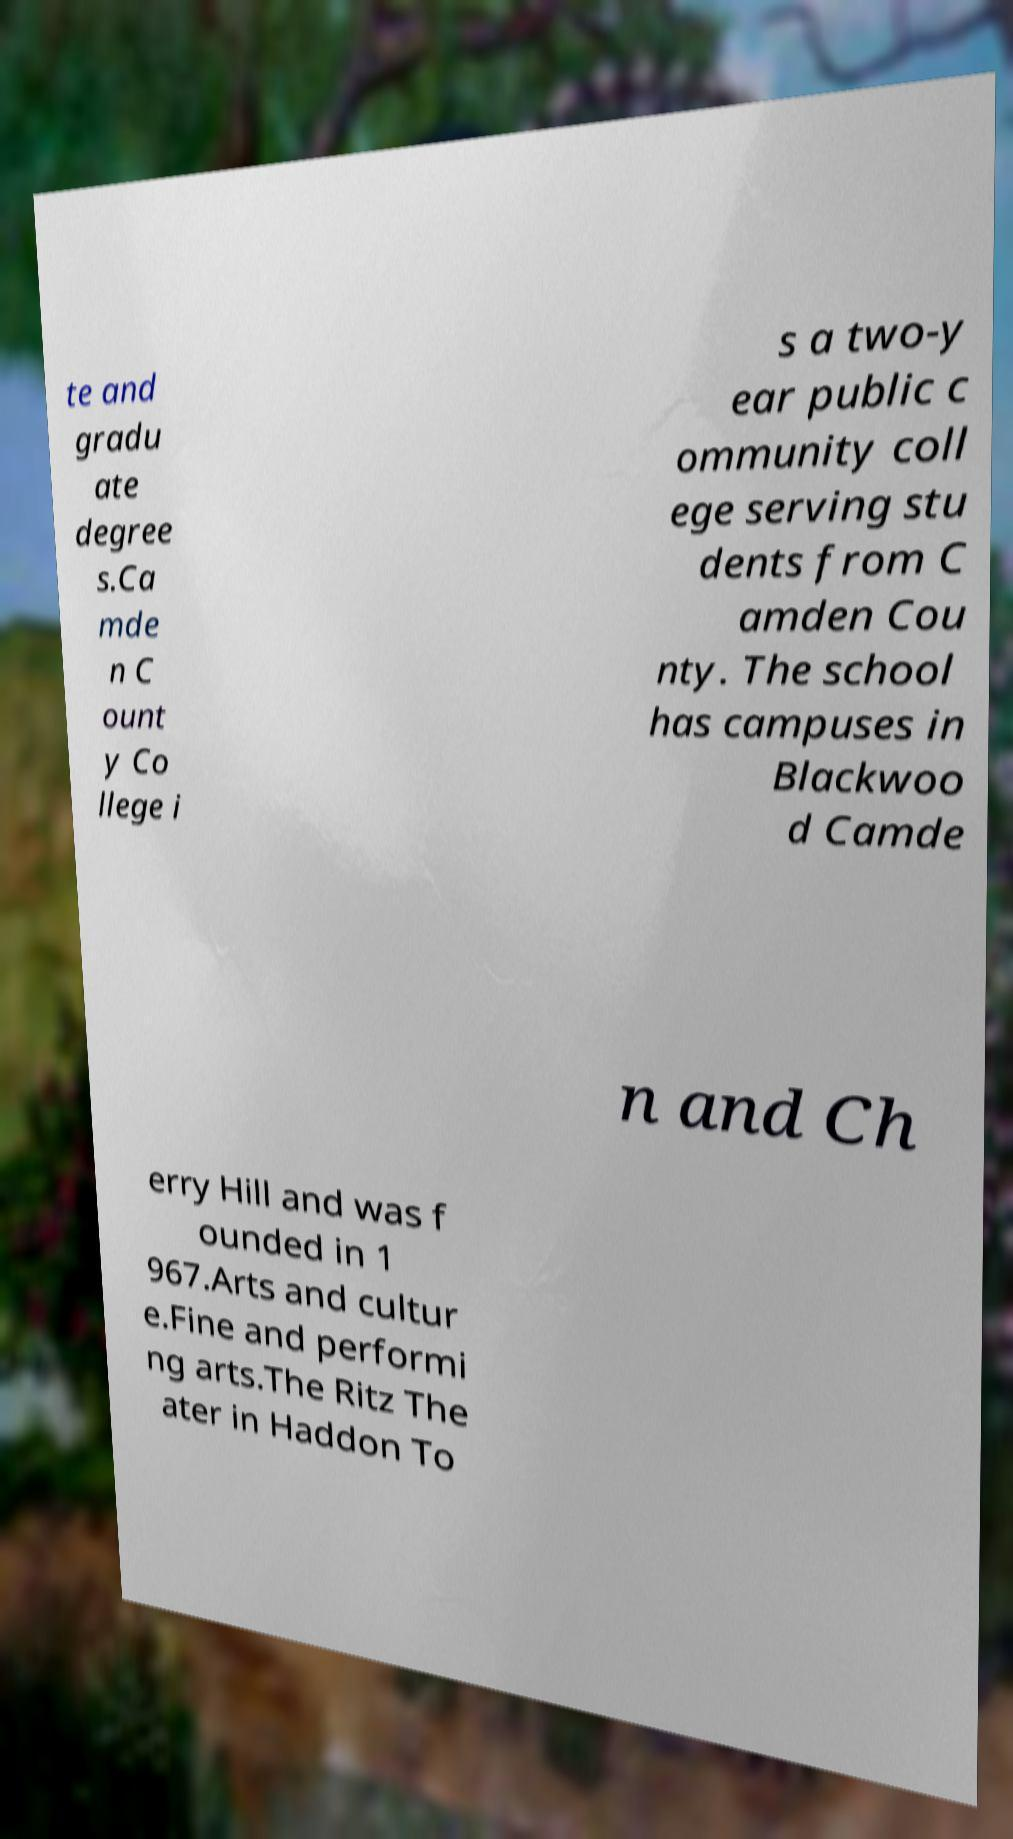Could you assist in decoding the text presented in this image and type it out clearly? te and gradu ate degree s.Ca mde n C ount y Co llege i s a two-y ear public c ommunity coll ege serving stu dents from C amden Cou nty. The school has campuses in Blackwoo d Camde n and Ch erry Hill and was f ounded in 1 967.Arts and cultur e.Fine and performi ng arts.The Ritz The ater in Haddon To 